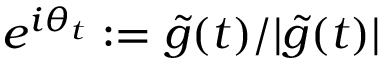Convert formula to latex. <formula><loc_0><loc_0><loc_500><loc_500>e ^ { i \theta _ { t } } \colon = \tilde { g } ( t ) / | \tilde { g } ( t ) |</formula> 